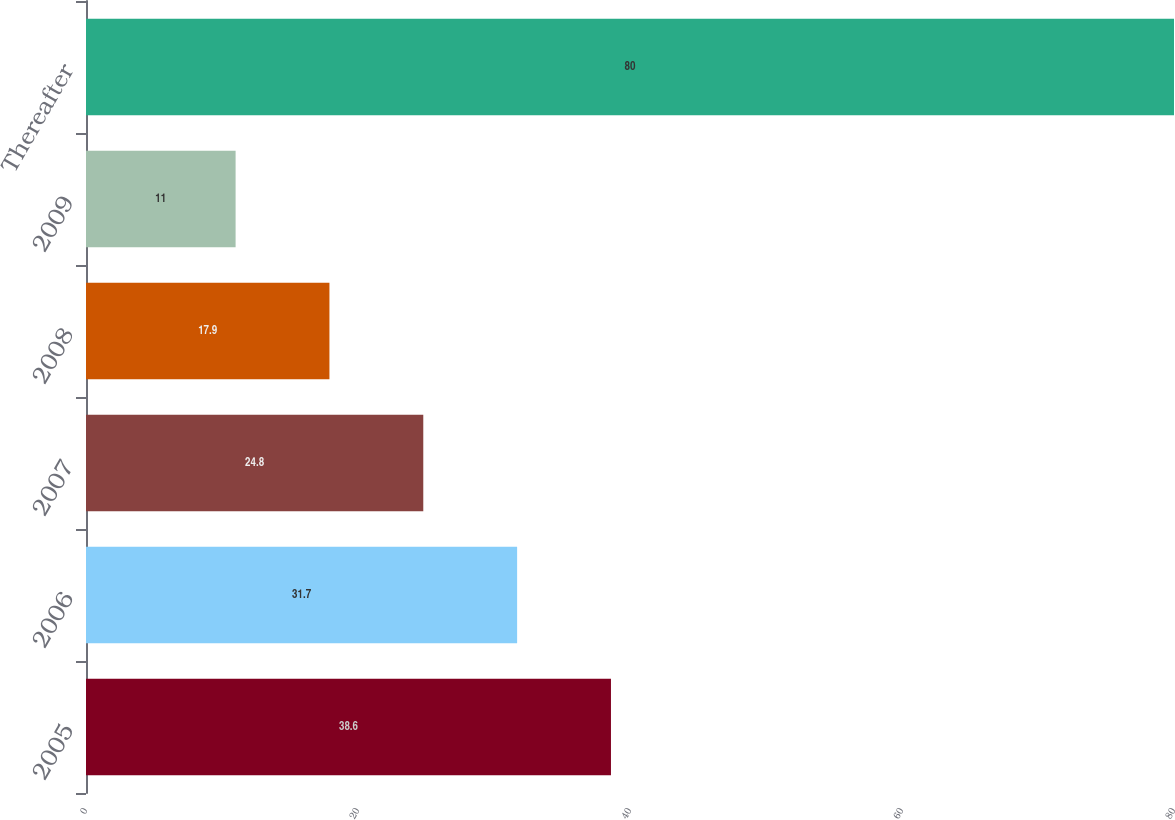<chart> <loc_0><loc_0><loc_500><loc_500><bar_chart><fcel>2005<fcel>2006<fcel>2007<fcel>2008<fcel>2009<fcel>Thereafter<nl><fcel>38.6<fcel>31.7<fcel>24.8<fcel>17.9<fcel>11<fcel>80<nl></chart> 